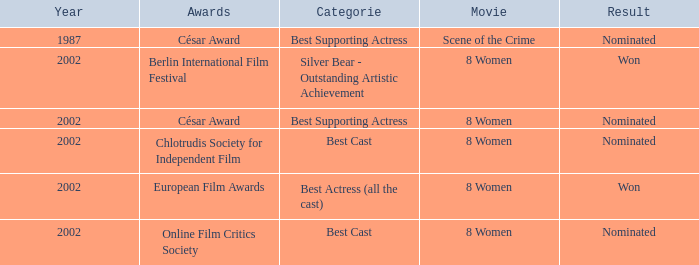What was the categorie in 2002 at the Berlin international Film Festival that Danielle Darrieux was in? Silver Bear - Outstanding Artistic Achievement. 